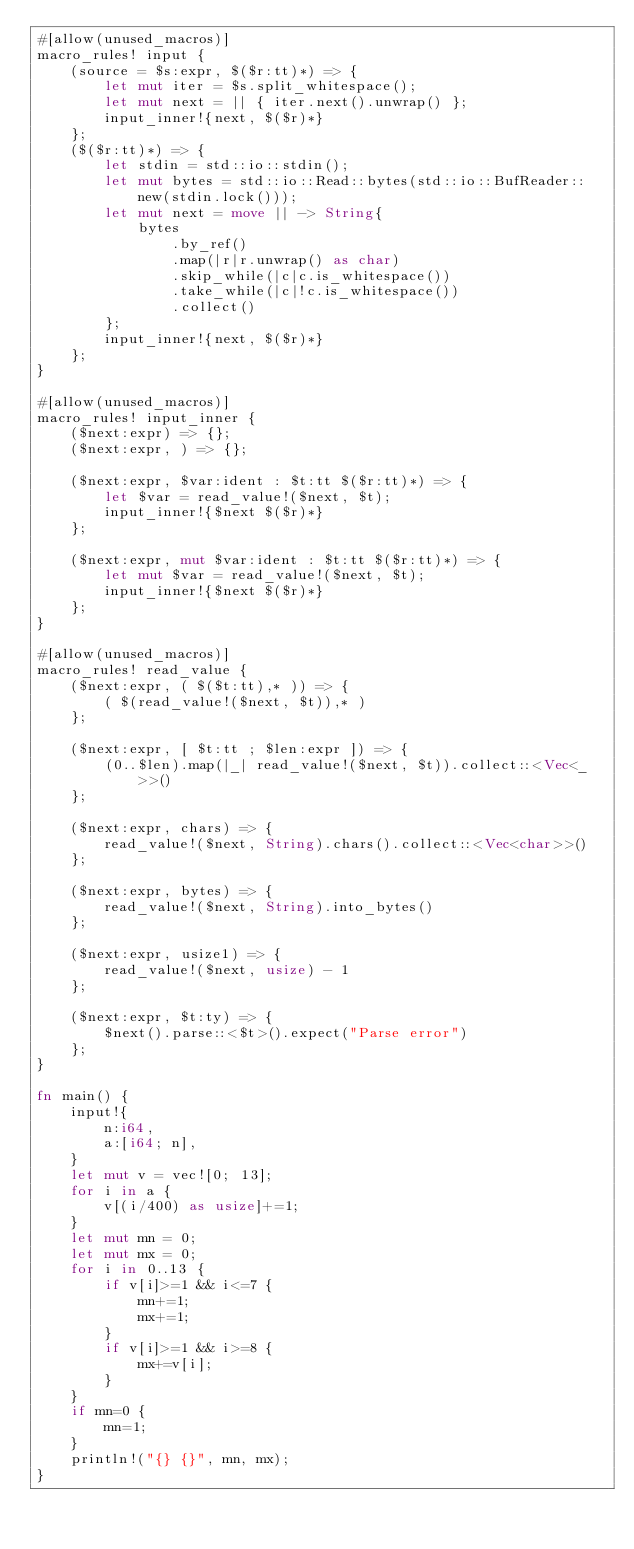<code> <loc_0><loc_0><loc_500><loc_500><_Rust_>#[allow(unused_macros)]
macro_rules! input {
    (source = $s:expr, $($r:tt)*) => {
        let mut iter = $s.split_whitespace();
        let mut next = || { iter.next().unwrap() };
        input_inner!{next, $($r)*}
    };
    ($($r:tt)*) => {
        let stdin = std::io::stdin();
        let mut bytes = std::io::Read::bytes(std::io::BufReader::new(stdin.lock()));
        let mut next = move || -> String{
            bytes
                .by_ref()
                .map(|r|r.unwrap() as char)
                .skip_while(|c|c.is_whitespace())
                .take_while(|c|!c.is_whitespace())
                .collect()
        };
        input_inner!{next, $($r)*}
    };
}

#[allow(unused_macros)]
macro_rules! input_inner {
    ($next:expr) => {};
    ($next:expr, ) => {};

    ($next:expr, $var:ident : $t:tt $($r:tt)*) => {
        let $var = read_value!($next, $t);
        input_inner!{$next $($r)*}
    };

    ($next:expr, mut $var:ident : $t:tt $($r:tt)*) => {
        let mut $var = read_value!($next, $t);
        input_inner!{$next $($r)*}
    };
}

#[allow(unused_macros)]
macro_rules! read_value {
    ($next:expr, ( $($t:tt),* )) => {
        ( $(read_value!($next, $t)),* )
    };

    ($next:expr, [ $t:tt ; $len:expr ]) => {
        (0..$len).map(|_| read_value!($next, $t)).collect::<Vec<_>>()
    };

    ($next:expr, chars) => {
        read_value!($next, String).chars().collect::<Vec<char>>()
    };

    ($next:expr, bytes) => {
        read_value!($next, String).into_bytes()
    };

    ($next:expr, usize1) => {
        read_value!($next, usize) - 1
    };

    ($next:expr, $t:ty) => {
        $next().parse::<$t>().expect("Parse error")
    };
}

fn main() {
    input!{
        n:i64,
        a:[i64; n],
    }
    let mut v = vec![0; 13];
    for i in a {
        v[(i/400) as usize]+=1;
    }
    let mut mn = 0;
    let mut mx = 0;
    for i in 0..13 {
        if v[i]>=1 && i<=7 {
            mn+=1;
            mx+=1;
        }
        if v[i]>=1 && i>=8 {
            mx+=v[i];
        }
    }
    if mn=0 {
        mn=1;
    }
    println!("{} {}", mn, mx);
}</code> 